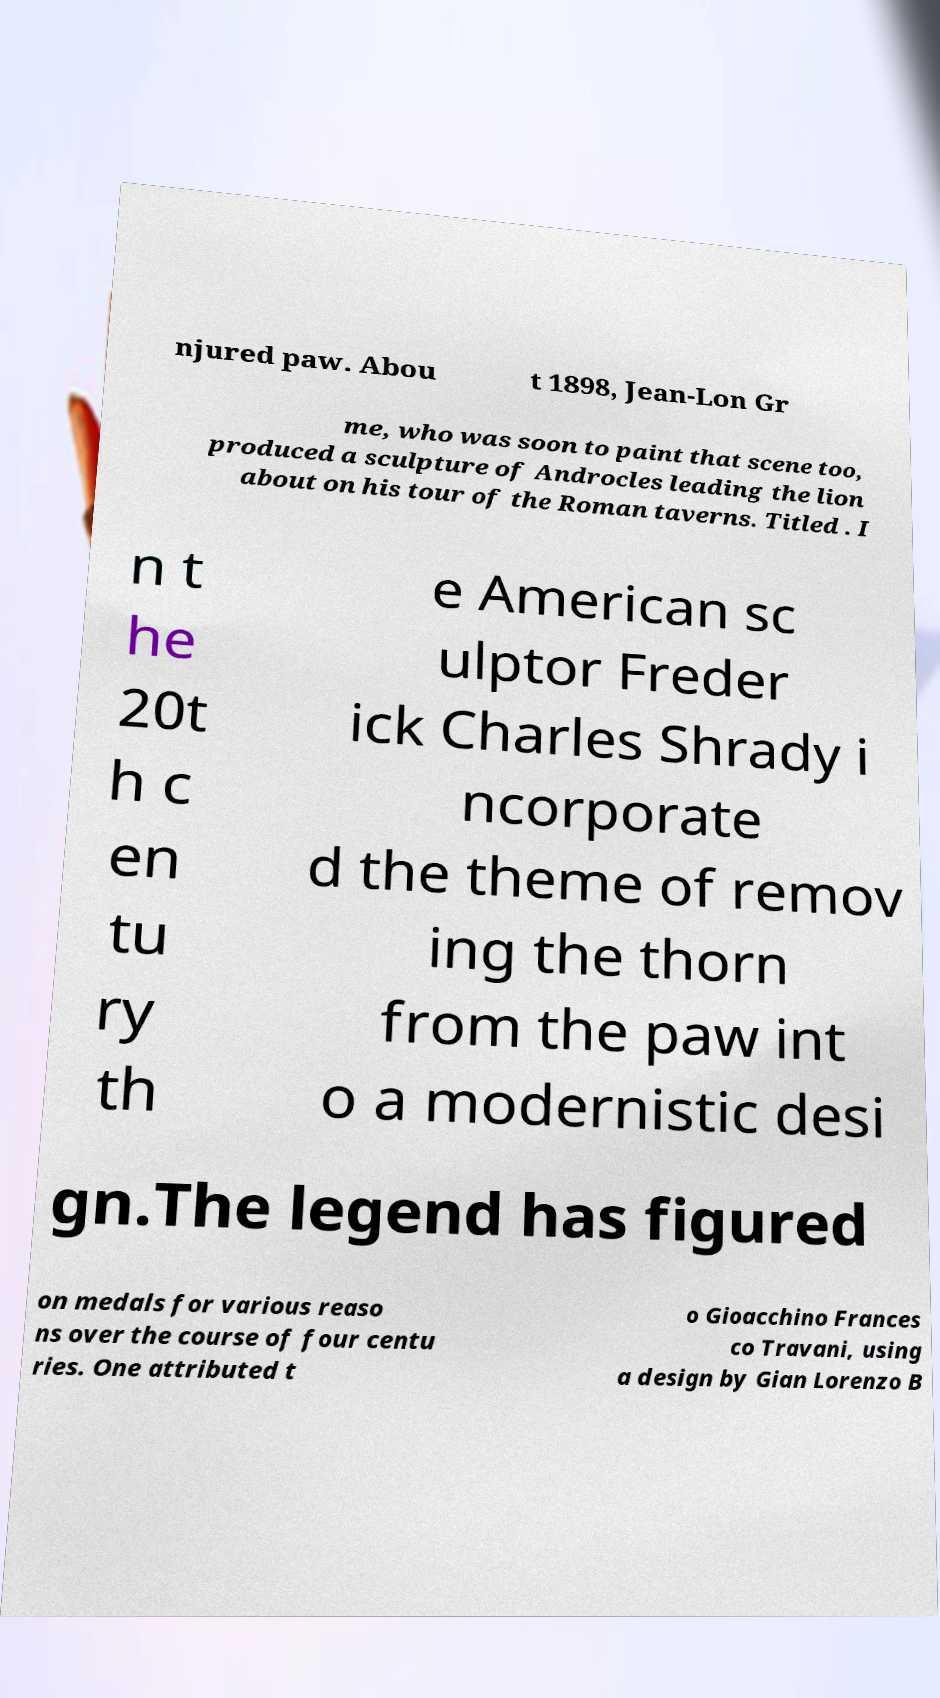Please identify and transcribe the text found in this image. njured paw. Abou t 1898, Jean-Lon Gr me, who was soon to paint that scene too, produced a sculpture of Androcles leading the lion about on his tour of the Roman taverns. Titled . I n t he 20t h c en tu ry th e American sc ulptor Freder ick Charles Shrady i ncorporate d the theme of remov ing the thorn from the paw int o a modernistic desi gn.The legend has figured on medals for various reaso ns over the course of four centu ries. One attributed t o Gioacchino Frances co Travani, using a design by Gian Lorenzo B 